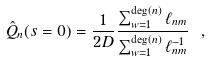Convert formula to latex. <formula><loc_0><loc_0><loc_500><loc_500>\hat { Q } _ { n } ( s = 0 ) = \frac { 1 } { 2 D } \frac { \sum _ { w = 1 } ^ { \text {deg} ( n ) } \ell _ { n m } } { \sum _ { w = 1 } ^ { \text {deg} ( n ) } \ell _ { n m } ^ { - 1 } } \ ,</formula> 